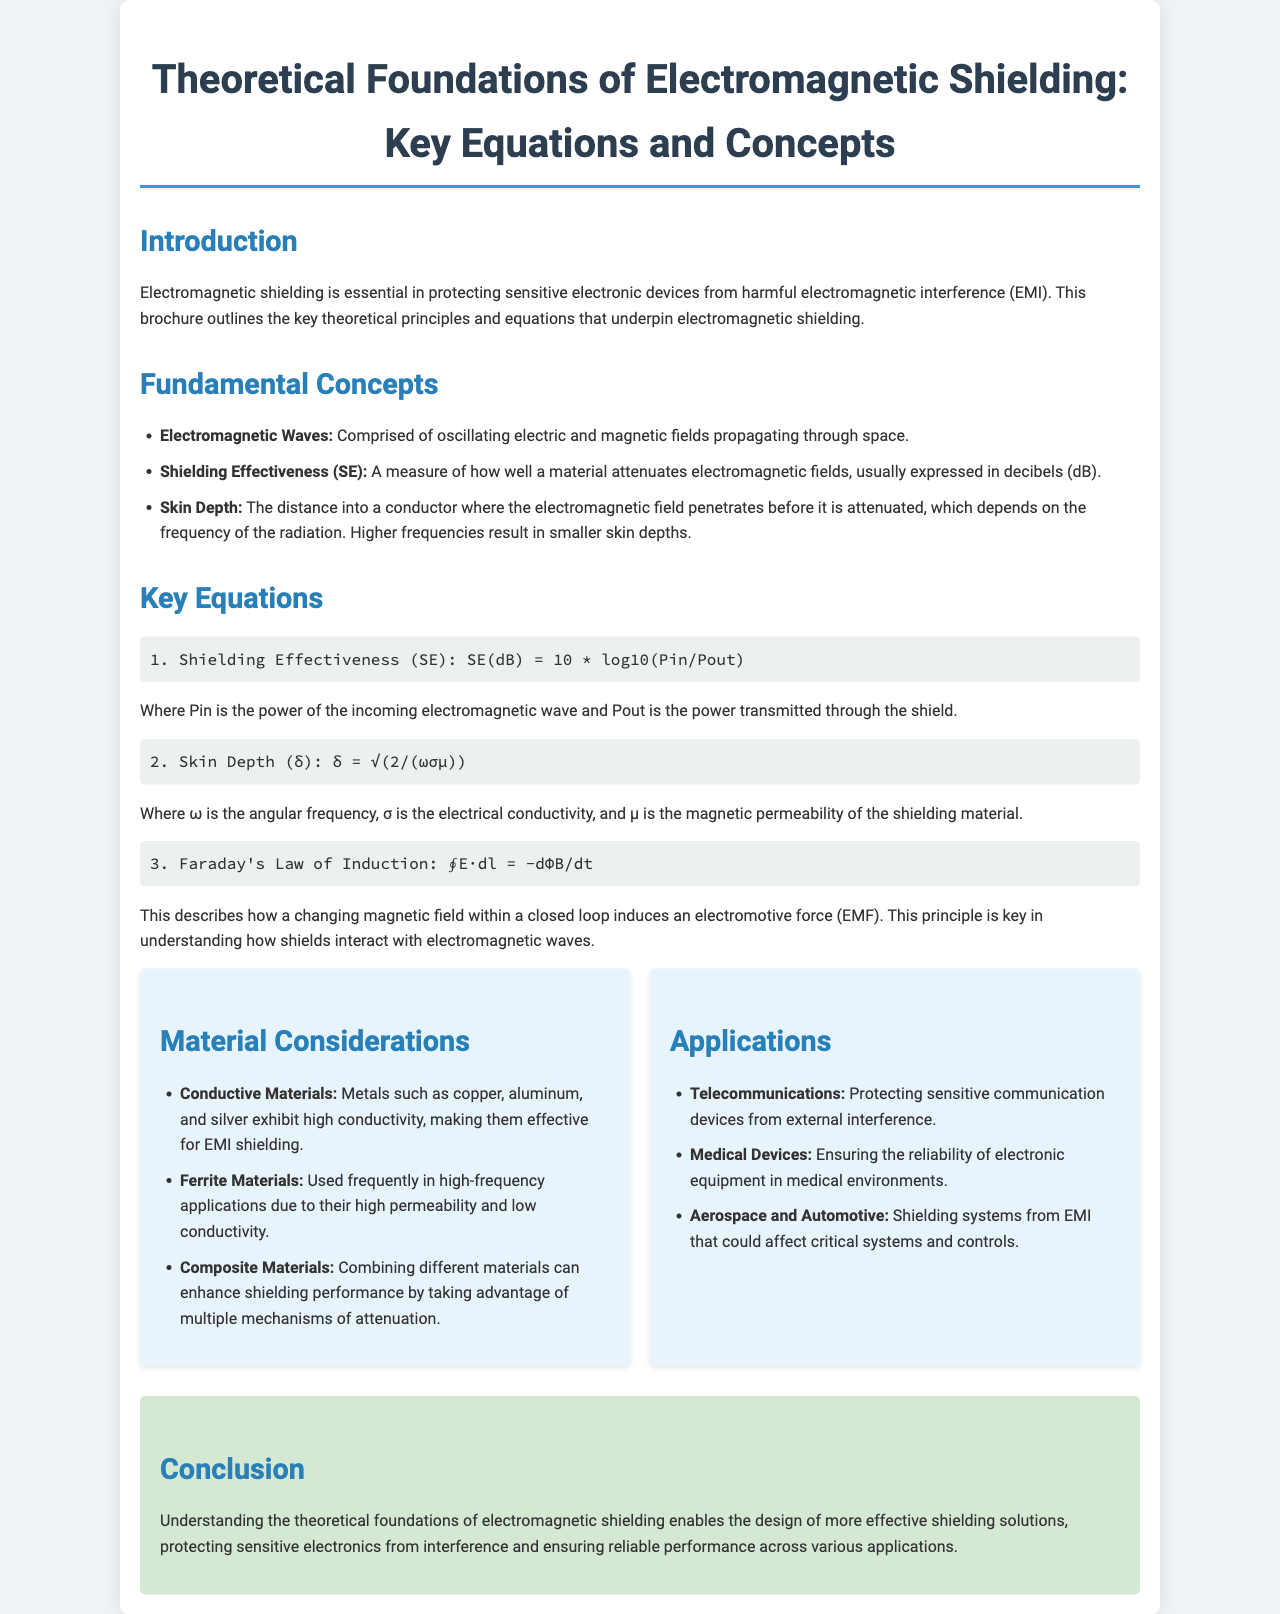What is the title of the brochure? The title of the brochure is stated prominently at the beginning of the document, highlighting the main topic.
Answer: Theoretical Foundations of Electromagnetic Shielding: Key Equations and Concepts What does SE stand for in the context of the document? The abbreviation SE in the document refers to a specific term related to shielding performance, which is defined in the fundamental concepts section.
Answer: Shielding Effectiveness What is the unit for Shielding Effectiveness? The unit mentioned in the document for measuring Shielding Effectiveness is specified in one of the key equations.
Answer: decibels (dB) What equation describes skin depth? An equation specifically related to skin depth is provided in the key equations section of the brochure.
Answer: δ = √(2/(ωσμ)) Which material is noted for high conductivity? The document lists several materials and highlights one that is particularly known for its high conductivity within the material considerations section.
Answer: Copper What is the relationship described by Faraday's Law of Induction? The specific law is referenced in the key equations section and represents a fundamental principle in the context of electromagnetic shielding.
Answer: Induces an electromotive force (EMF) Name one application of electromagnetic shielding. The brochure discusses various applications in a specific section, naming several fields where electromagnetic shielding is crucial.
Answer: Telecommunications What does the skin depth depend on? The document explains the factors that influence skin depth in the equation provided for it.
Answer: Frequency of the radiation What is the overall goal of understanding electromagnetic shielding? The brochure concludes with the primary aim of comprehending the topic, which is summarized succinctly in the conclusion.
Answer: Design of more effective shielding solutions 